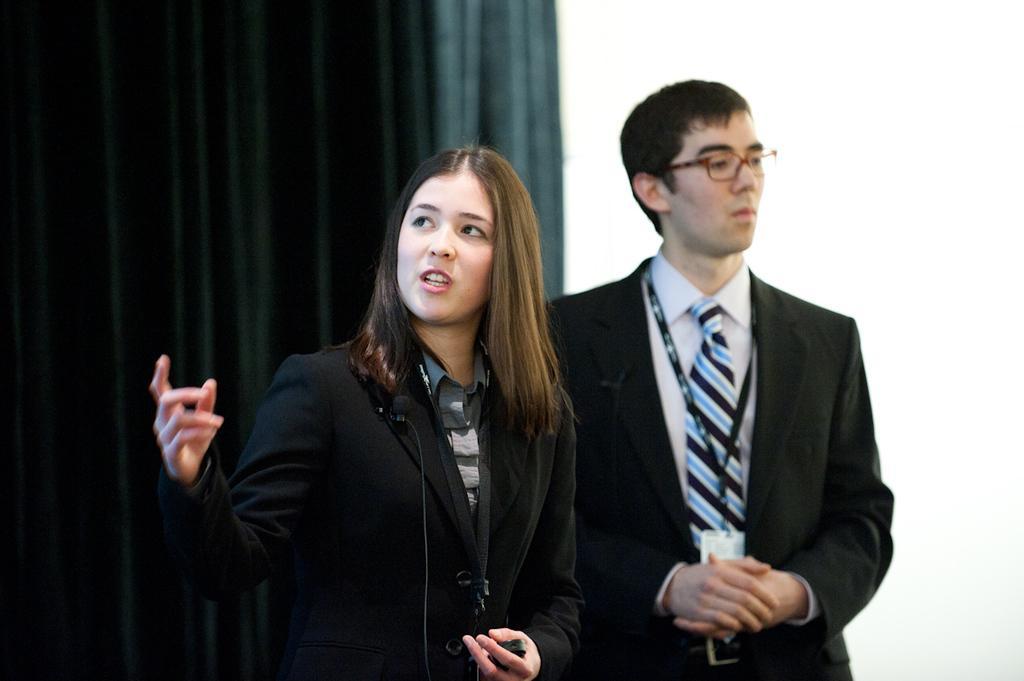Could you give a brief overview of what you see in this image? In this image we can see a woman standing and holding an object in her hand and it looks like she is talking and to the side there is a man standing and wearing spectacles and in the background, we can see the curtains. 